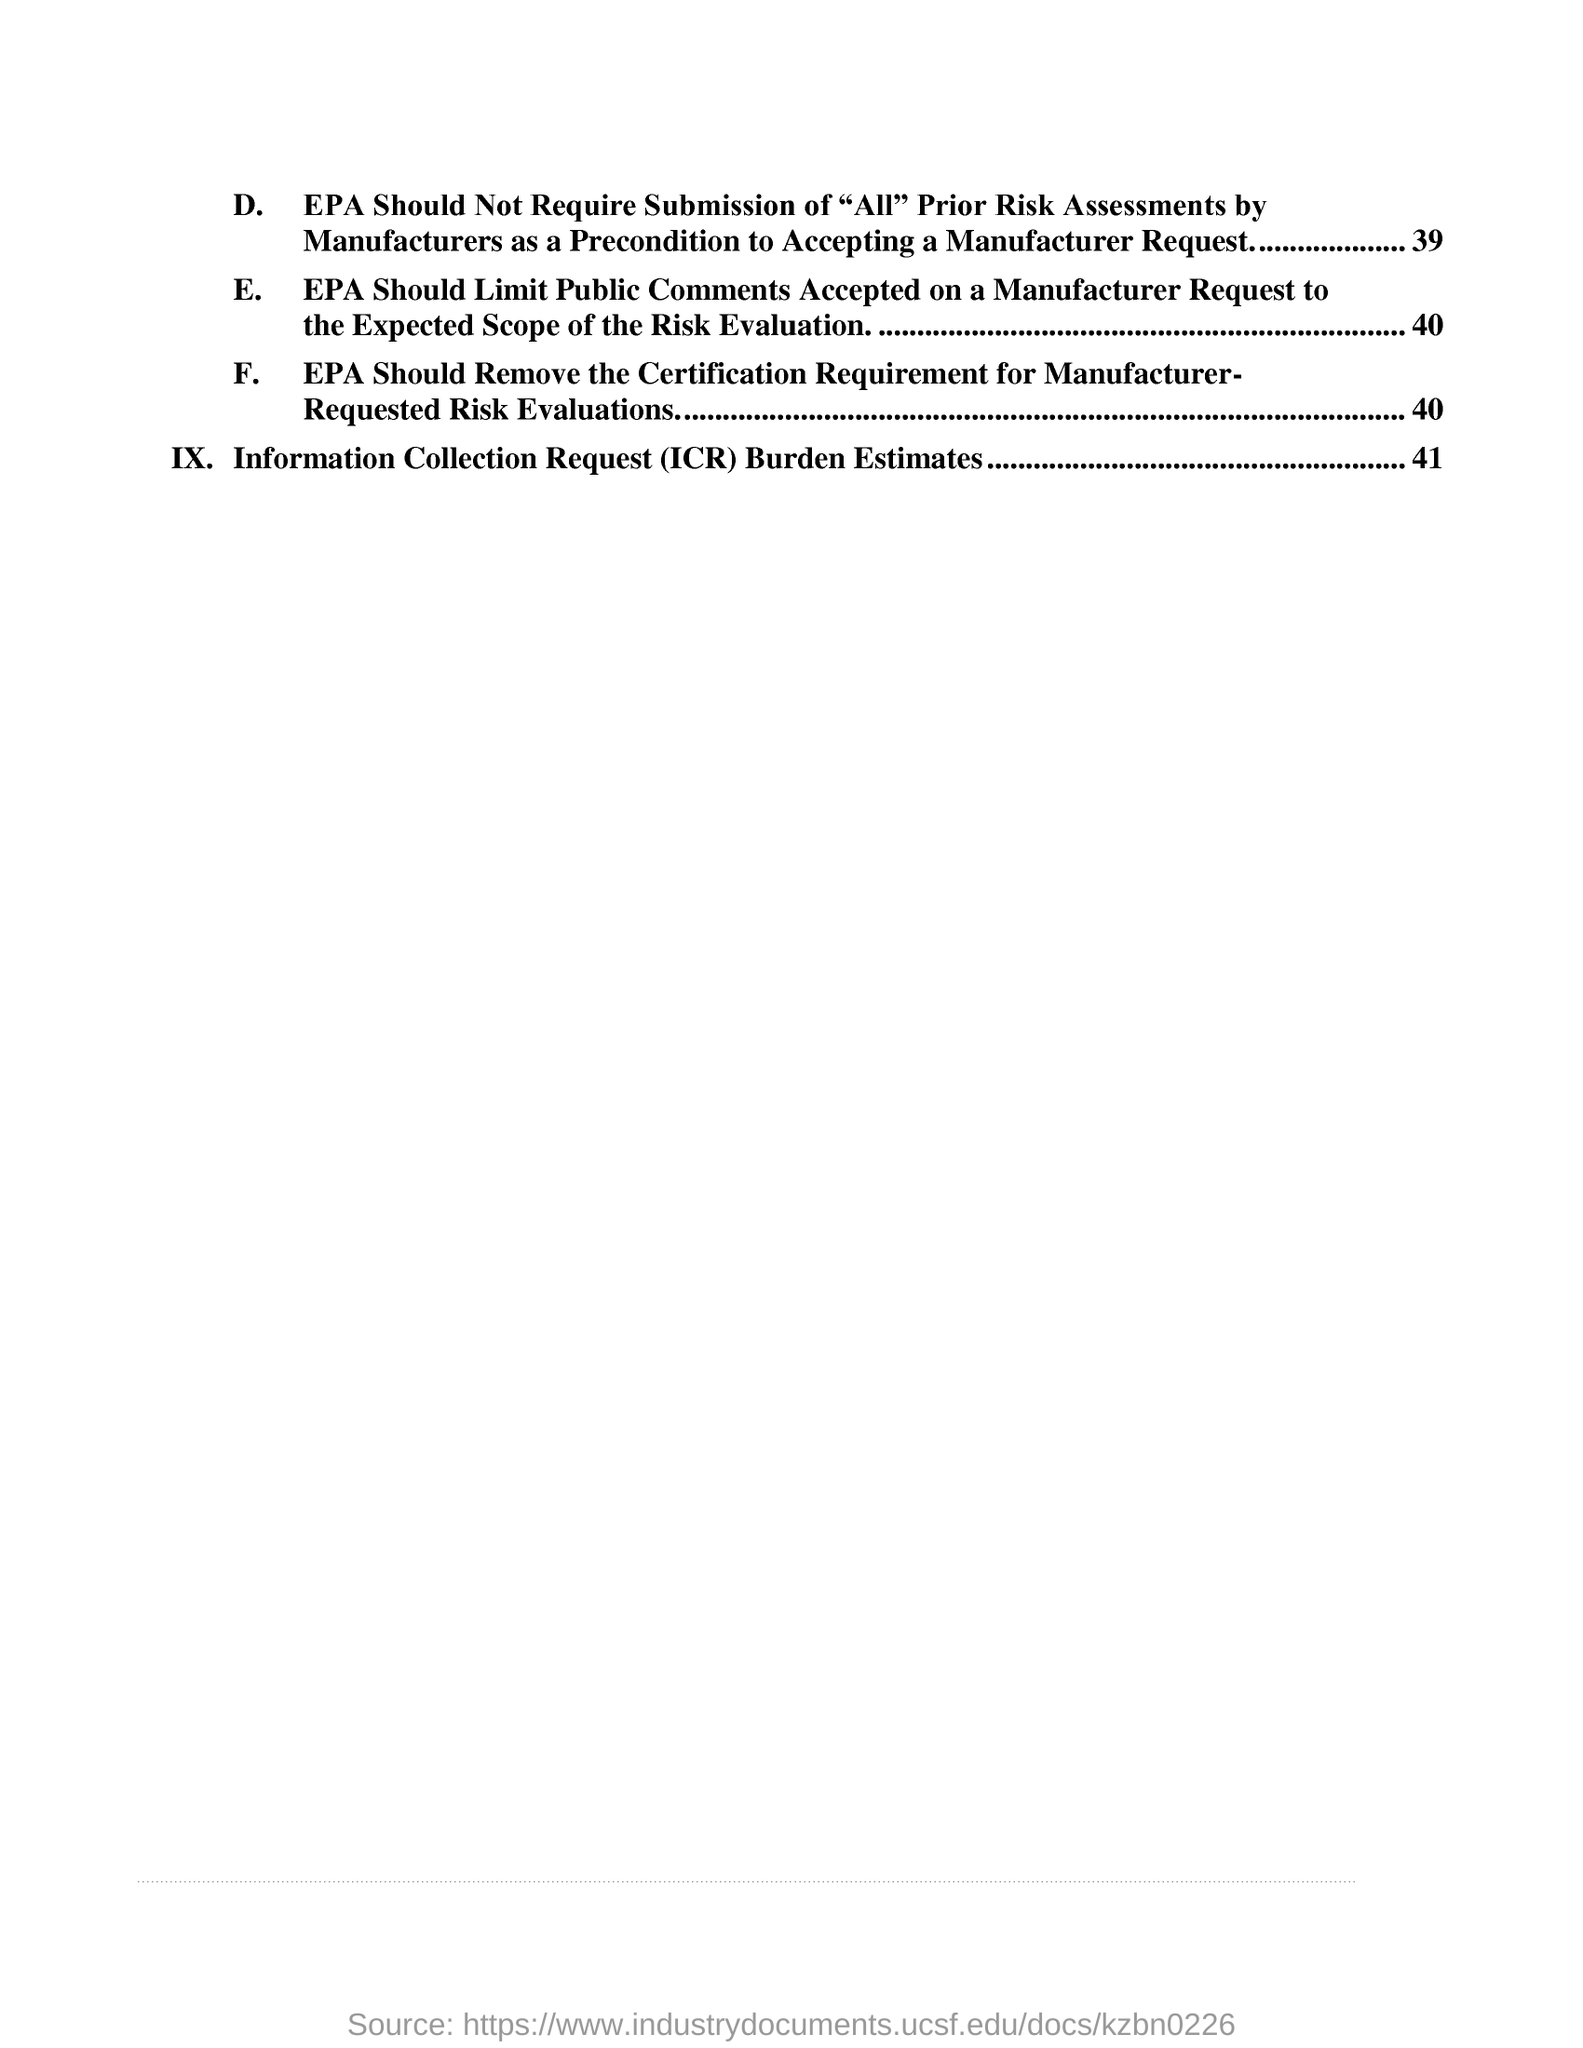What is the fullform of ICR?
Offer a very short reply. Information Collection Request. 